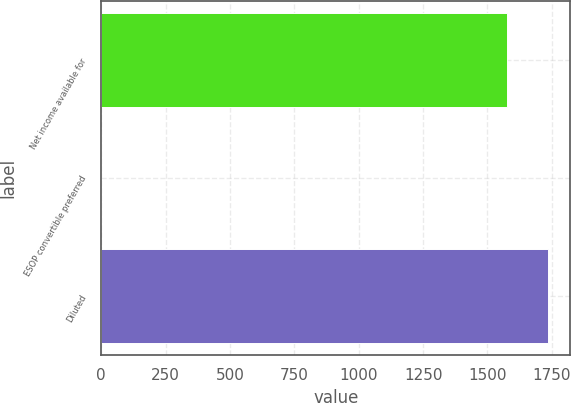Convert chart to OTSL. <chart><loc_0><loc_0><loc_500><loc_500><bar_chart><fcel>Net income available for<fcel>ESOP convertible preferred<fcel>Diluted<nl><fcel>1576<fcel>1<fcel>1735.6<nl></chart> 